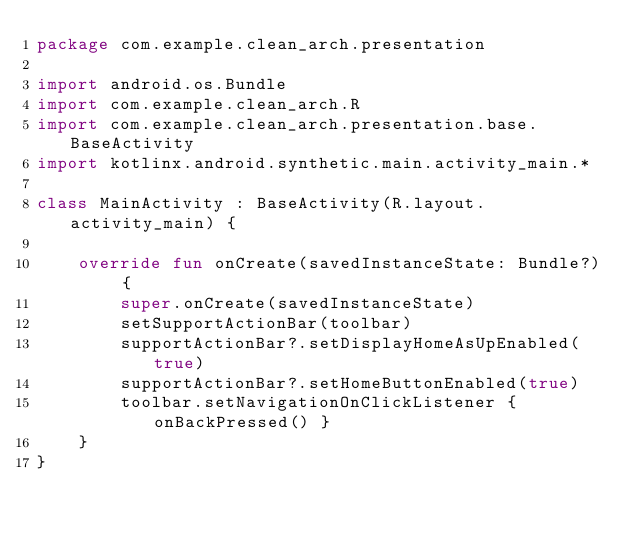<code> <loc_0><loc_0><loc_500><loc_500><_Kotlin_>package com.example.clean_arch.presentation

import android.os.Bundle
import com.example.clean_arch.R
import com.example.clean_arch.presentation.base.BaseActivity
import kotlinx.android.synthetic.main.activity_main.*

class MainActivity : BaseActivity(R.layout.activity_main) {

    override fun onCreate(savedInstanceState: Bundle?) {
        super.onCreate(savedInstanceState)
        setSupportActionBar(toolbar)
        supportActionBar?.setDisplayHomeAsUpEnabled(true)
        supportActionBar?.setHomeButtonEnabled(true)
        toolbar.setNavigationOnClickListener { onBackPressed() }
    }
}</code> 